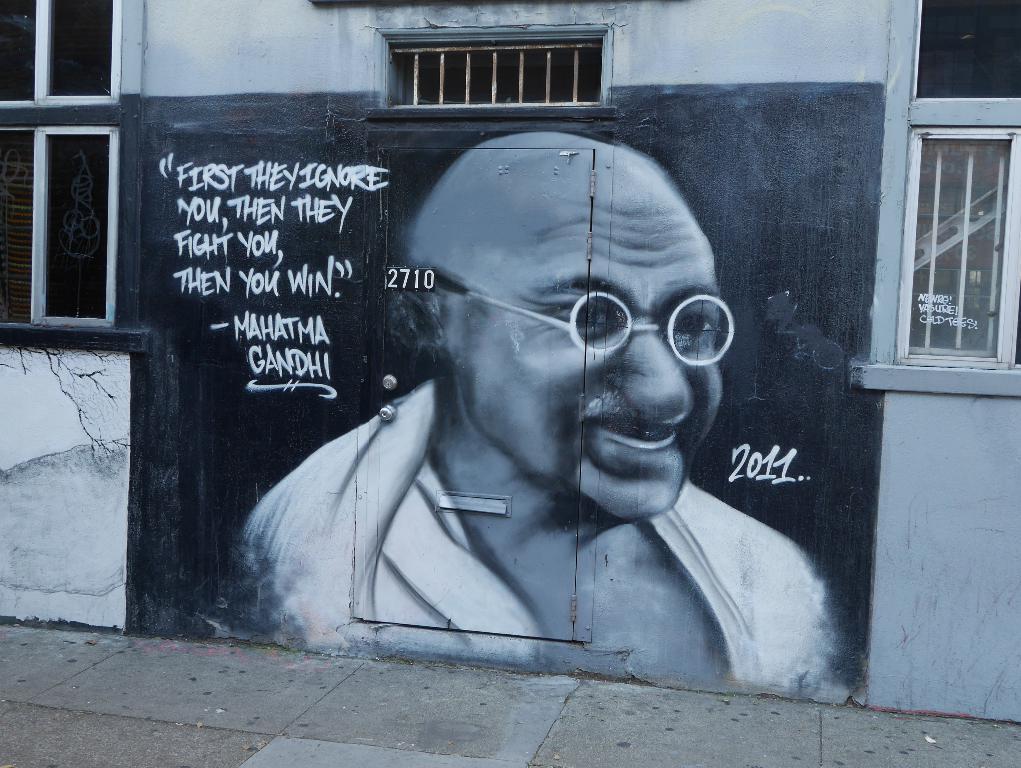Please provide a concise description of this image. In the middle it is an image of mahatma Gandhi on the wall, there are windows on either side of this image. 